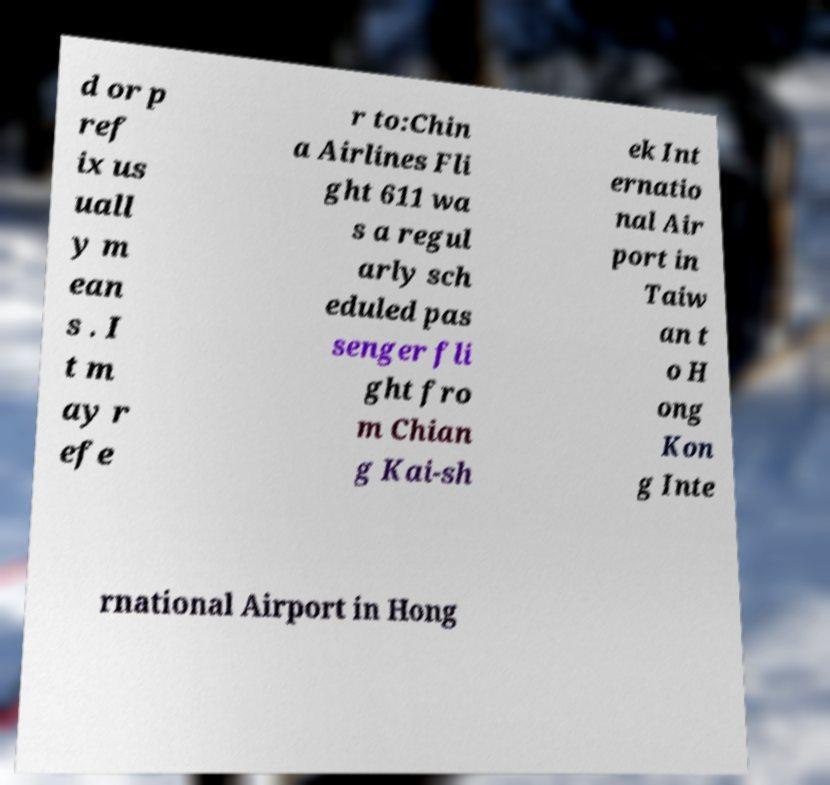Please identify and transcribe the text found in this image. d or p ref ix us uall y m ean s . I t m ay r efe r to:Chin a Airlines Fli ght 611 wa s a regul arly sch eduled pas senger fli ght fro m Chian g Kai-sh ek Int ernatio nal Air port in Taiw an t o H ong Kon g Inte rnational Airport in Hong 